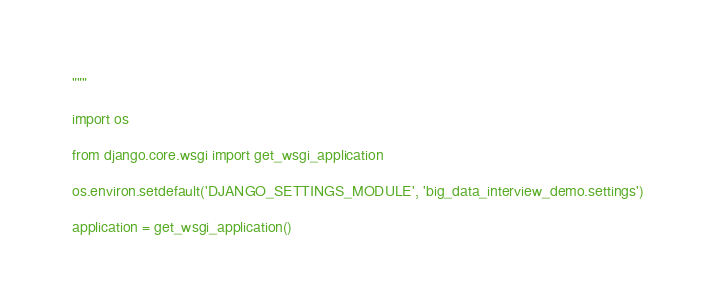Convert code to text. <code><loc_0><loc_0><loc_500><loc_500><_Python_>"""

import os

from django.core.wsgi import get_wsgi_application

os.environ.setdefault('DJANGO_SETTINGS_MODULE', 'big_data_interview_demo.settings')

application = get_wsgi_application()
</code> 